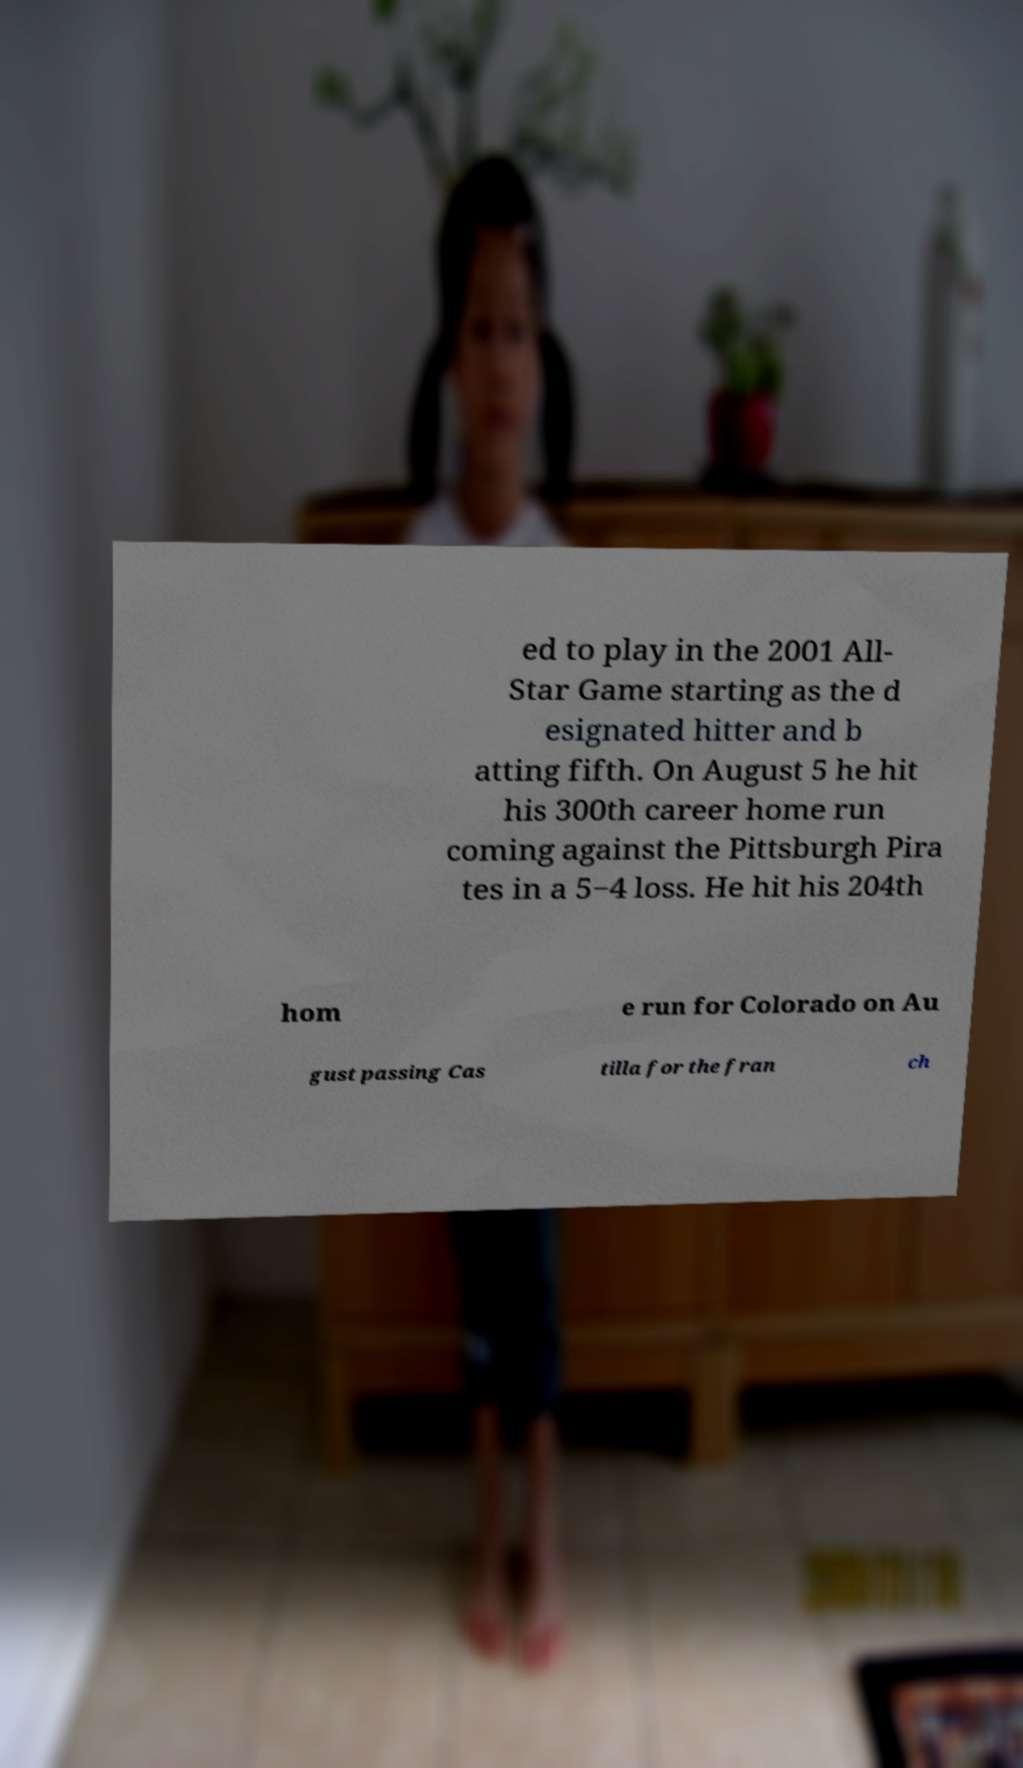Could you assist in decoding the text presented in this image and type it out clearly? ed to play in the 2001 All- Star Game starting as the d esignated hitter and b atting fifth. On August 5 he hit his 300th career home run coming against the Pittsburgh Pira tes in a 5−4 loss. He hit his 204th hom e run for Colorado on Au gust passing Cas tilla for the fran ch 